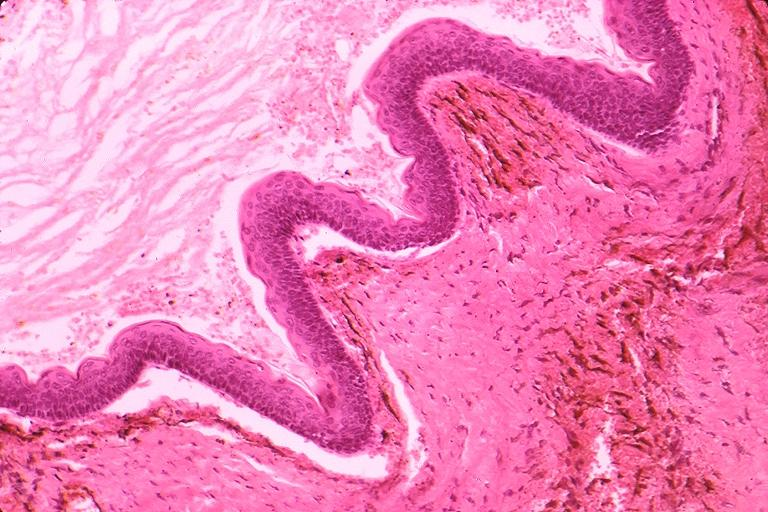what does this image show?
Answer the question using a single word or phrase. Odontogenic keratocyst 